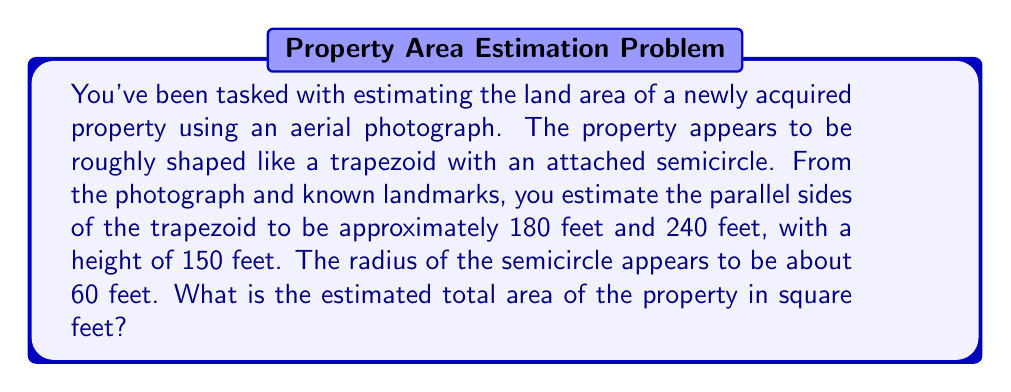What is the answer to this math problem? Let's break this problem down step-by-step:

1. Calculate the area of the trapezoid:
   The formula for the area of a trapezoid is:
   $$A_{trapezoid} = \frac{1}{2}(b_1 + b_2)h$$
   where $b_1$ and $b_2$ are the parallel sides and $h$ is the height.

   $$A_{trapezoid} = \frac{1}{2}(180 + 240) \times 150$$
   $$A_{trapezoid} = \frac{1}{2}(420) \times 150 = 210 \times 150 = 31,500 \text{ sq ft}$$

2. Calculate the area of the semicircle:
   The formula for the area of a circle is $\pi r^2$, so for a semicircle it's:
   $$A_{semicircle} = \frac{1}{2}\pi r^2$$

   $$A_{semicircle} = \frac{1}{2} \times \pi \times 60^2$$
   $$A_{semicircle} = \frac{1}{2} \times \pi \times 3600 = 1800\pi \approx 5,654.87 \text{ sq ft}$$

3. Sum the areas:
   $$A_{total} = A_{trapezoid} + A_{semicircle}$$
   $$A_{total} = 31,500 + 5,654.87 = 37,154.87 \text{ sq ft}$$

4. Round to a reasonable precision:
   Given that these are estimates from an aerial photograph, it's appropriate to round to the nearest 100 square feet.

   $$A_{total} \approx 37,200 \text{ sq ft}$$

[asy]
import geometry;

size(200);

pair A = (0,0);
pair B = (180,0);
pair C = (240,150);
pair D = (-60,150);
pair O = (240,150);

draw(A--B--C--D--cycle);
draw(arc(O,60,180,360));

label("180'", (90,-10));
label("240'", (210,160));
label("150'", (-75,75));
label("r=60'", (180,150));
[/asy]
Answer: The estimated total area of the property is approximately 37,200 square feet. 